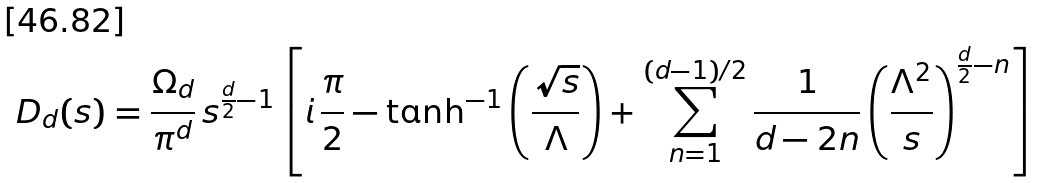Convert formula to latex. <formula><loc_0><loc_0><loc_500><loc_500>D _ { d } ( s ) = \frac { \Omega _ { d } } { \pi ^ { d } } \, s ^ { \frac { d } { 2 } - 1 } \left [ i \, \frac { \pi } { 2 } - \tanh ^ { - 1 } \left ( \frac { \sqrt { s } } { \Lambda } \right ) + \sum _ { n = 1 } ^ { ( d - 1 ) / 2 } \frac { 1 } { d - 2 n } \left ( \frac { \Lambda ^ { 2 } } { s } \right ) ^ { \frac { d } { 2 } - n } \right ]</formula> 